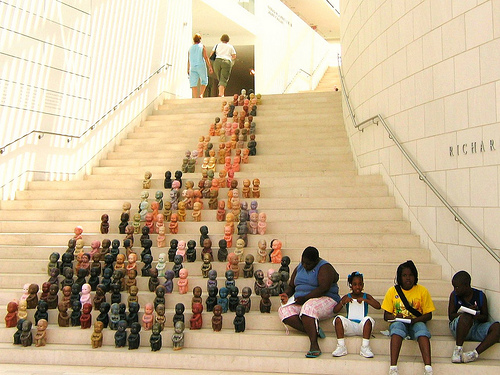<image>
Can you confirm if the doll is on the stairs? Yes. Looking at the image, I can see the doll is positioned on top of the stairs, with the stairs providing support. Is the shoes on the woman? No. The shoes is not positioned on the woman. They may be near each other, but the shoes is not supported by or resting on top of the woman. Where is the doll in relation to the doll? Is it in front of the doll? Yes. The doll is positioned in front of the doll, appearing closer to the camera viewpoint. Where is the statue in relation to the person? Is it in front of the person? No. The statue is not in front of the person. The spatial positioning shows a different relationship between these objects. Is the girl to the left of the woman? Yes. From this viewpoint, the girl is positioned to the left side relative to the woman. 